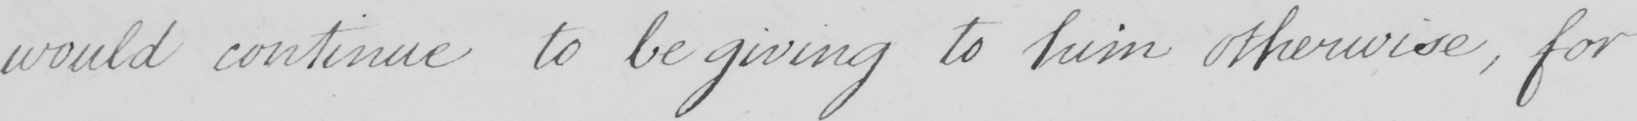What does this handwritten line say? would continue to be giving to him otherwise , for 